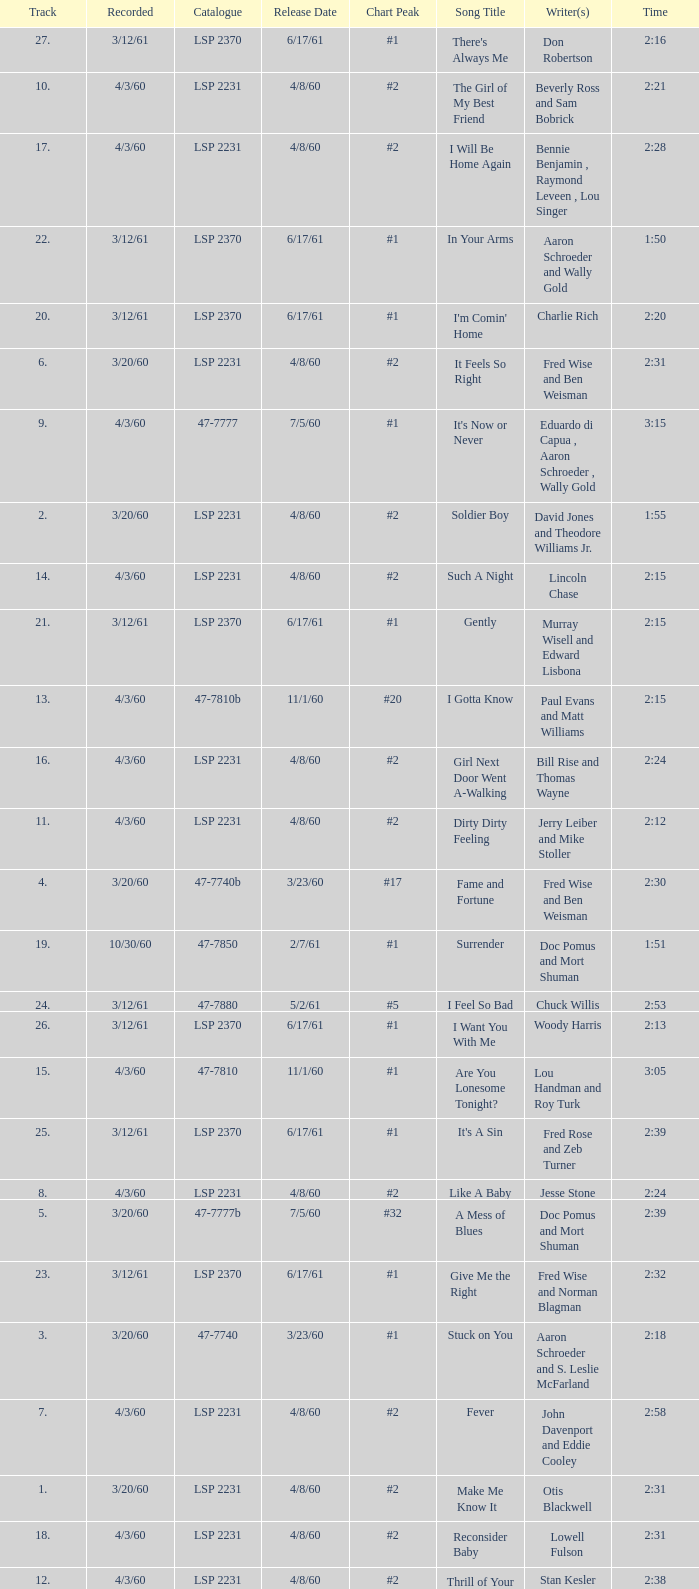On songs with track numbers smaller than number 17 and catalogues of LSP 2231, who are the writer(s)? Otis Blackwell, David Jones and Theodore Williams Jr., Fred Wise and Ben Weisman, John Davenport and Eddie Cooley, Jesse Stone, Beverly Ross and Sam Bobrick, Jerry Leiber and Mike Stoller, Stan Kesler, Lincoln Chase, Bill Rise and Thomas Wayne. 